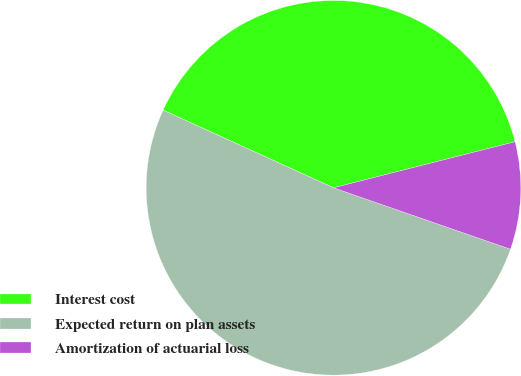<chart> <loc_0><loc_0><loc_500><loc_500><pie_chart><fcel>Interest cost<fcel>Expected return on plan assets<fcel>Amortization of actuarial loss<nl><fcel>39.24%<fcel>51.49%<fcel>9.27%<nl></chart> 